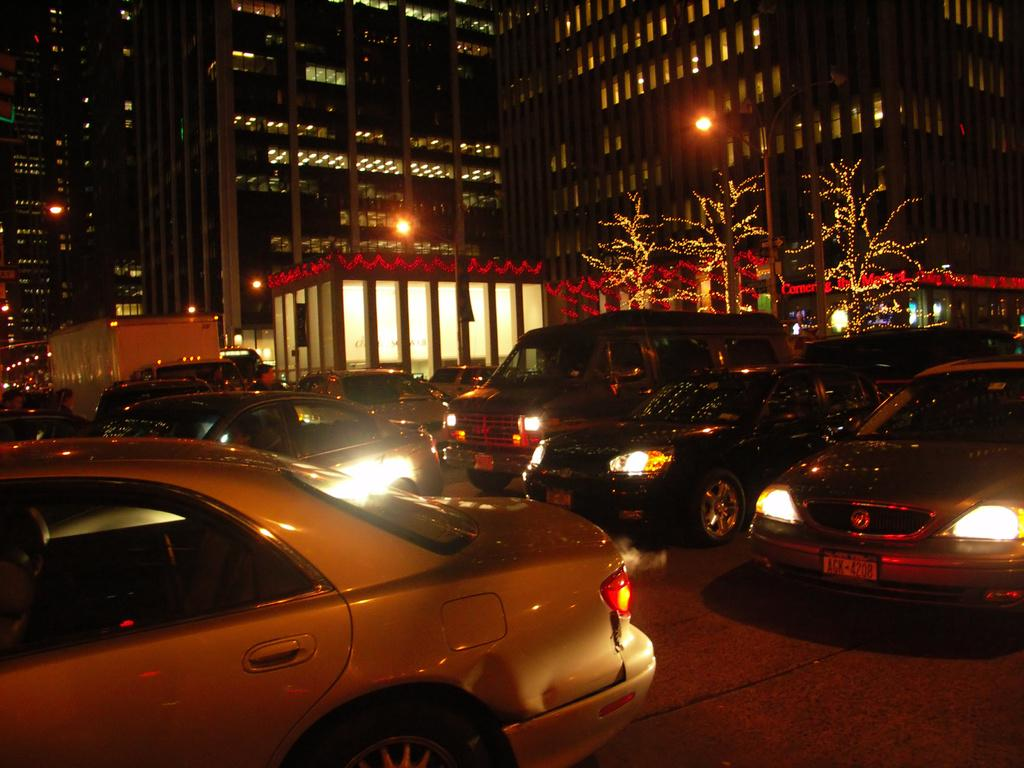What is the main subject in the center of the image? There are cars in the center of the image. What can be seen in the background of the image? There are buildings in the background of the image. What is at the bottom of the image? There is a road at the bottom of the image. What type of apparel is being worn by the wilderness in the image? There is no wilderness or apparel present in the image. 